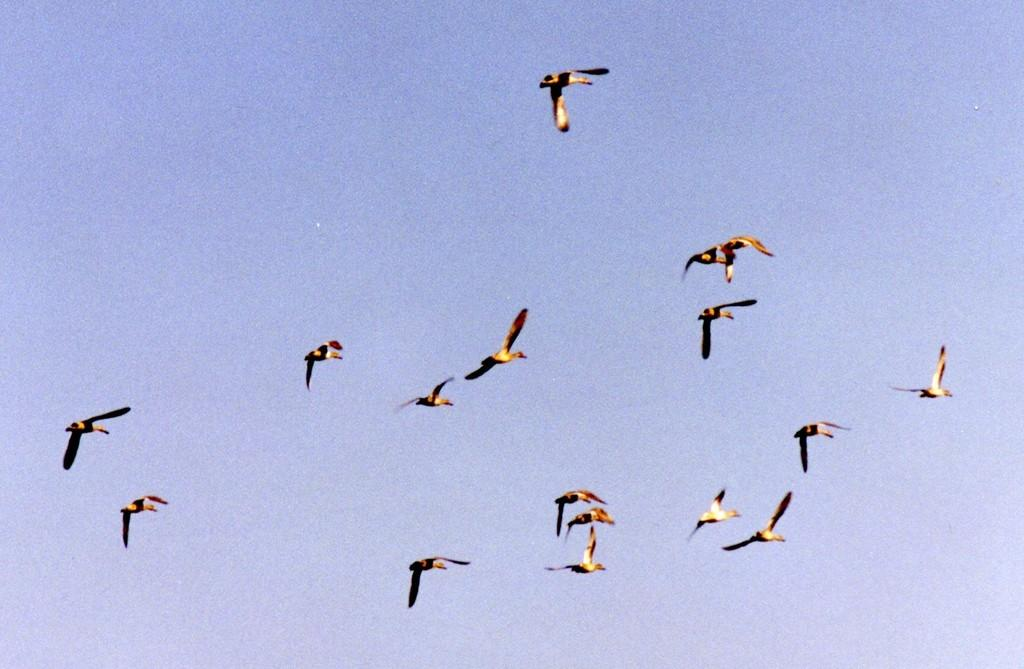What is the main subject of the image? The main subject of the image is many birds. What are the birds doing in the image? The birds are flying in the sky. What colors can be seen on the birds in the image? The birds are in black, brown, and yellow colors. What is visible in the background of the image? The sky is visible in the background of the image. What is the color of the sky in the image? The sky is blue in color. What type of event is happening with the cattle in the image? There are no cattle present in the image; it features many birds flying in the sky. Can you tell me how many lines are visible in the image? There are no lines present in the image; it is a photograph of birds flying in the sky against a blue background. 